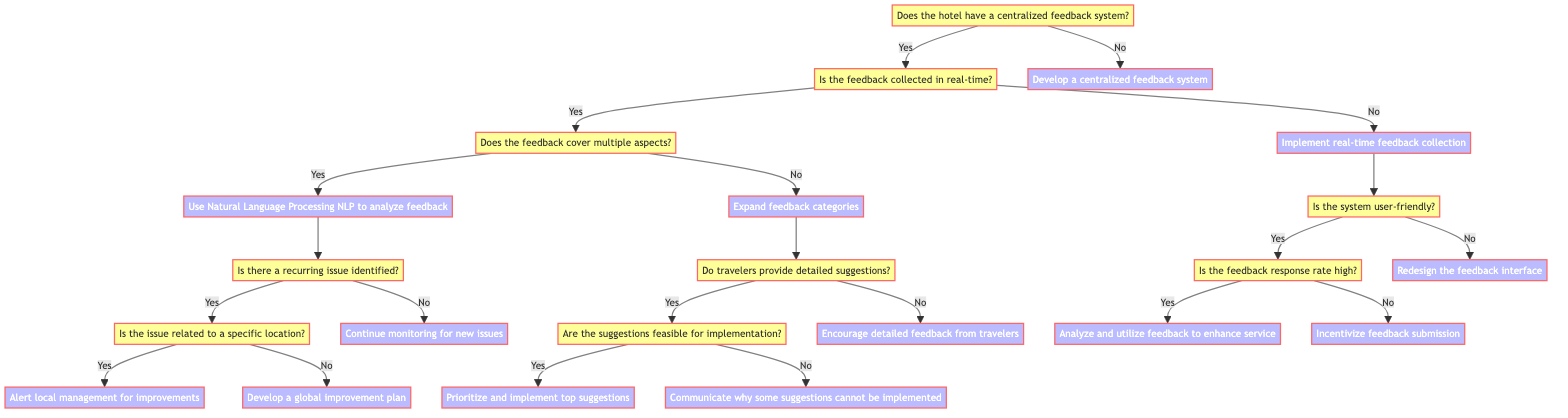What's the first question posed in the diagram? The diagram starts with the root question, which is "Does the hotel have a centralized feedback system?" This root node sets the stage for the entire decision process.
Answer: Does the hotel have a centralized feedback system? How many actions follow the "Does the hotel have a centralized feedback system?" question? There are two possible actions directly linked to this question: one for 'yes' which leads to further inquiries, and one for 'no' which leads to the action "Develop a centralized feedback system." This means there are two distinct paths.
Answer: Two actions What action is taken if feedback is not collected in real-time? If feedback is not collected in real-time, the action taken is "Implement real-time feedback collection." This indicates that improving the system for collecting feedback is a priority.
Answer: Implement real-time feedback collection What happens if feedback covers multiple aspects? If the feedback covers multiple aspects, the action taken is to "Use Natural Language Processing (NLP) to analyze feedback." This step suggests a systematic approach to gain insights from the diverse feedback metrics.
Answer: Use Natural Language Processing (NLP) to analyze feedback If there is a recurring issue identified and it is not related to a specific location, what is the next action? If a recurring issue is identified but it is not location-specific, the action taken is to "Develop a global improvement plan." This indicates a broad strategy to address the issue across all locations.
Answer: Develop a global improvement plan What is the next step if travelers do not provide detailed suggestions? If travelers do not provide detailed suggestions, the next step is to "Encourage detailed feedback from travelers." This action emphasizes the importance of comprehensive input from guests for improvement.
Answer: Encourage detailed feedback from travelers What is the consequence of having a user-friendly feedback system with a high feedback response rate? With a user-friendly system and a high feedback response rate, the consequence is "Analyze and utilize feedback to enhance service." This highlights the effective use of collected feedback for service improvement.
Answer: Analyze and utilize feedback to enhance service What should be done if the feedback response rate is low? If the feedback response rate is low, the action advised is to "Incentivize feedback submission." This encourages guests to participate more in providing their opinions.
Answer: Incentivize feedback submission 